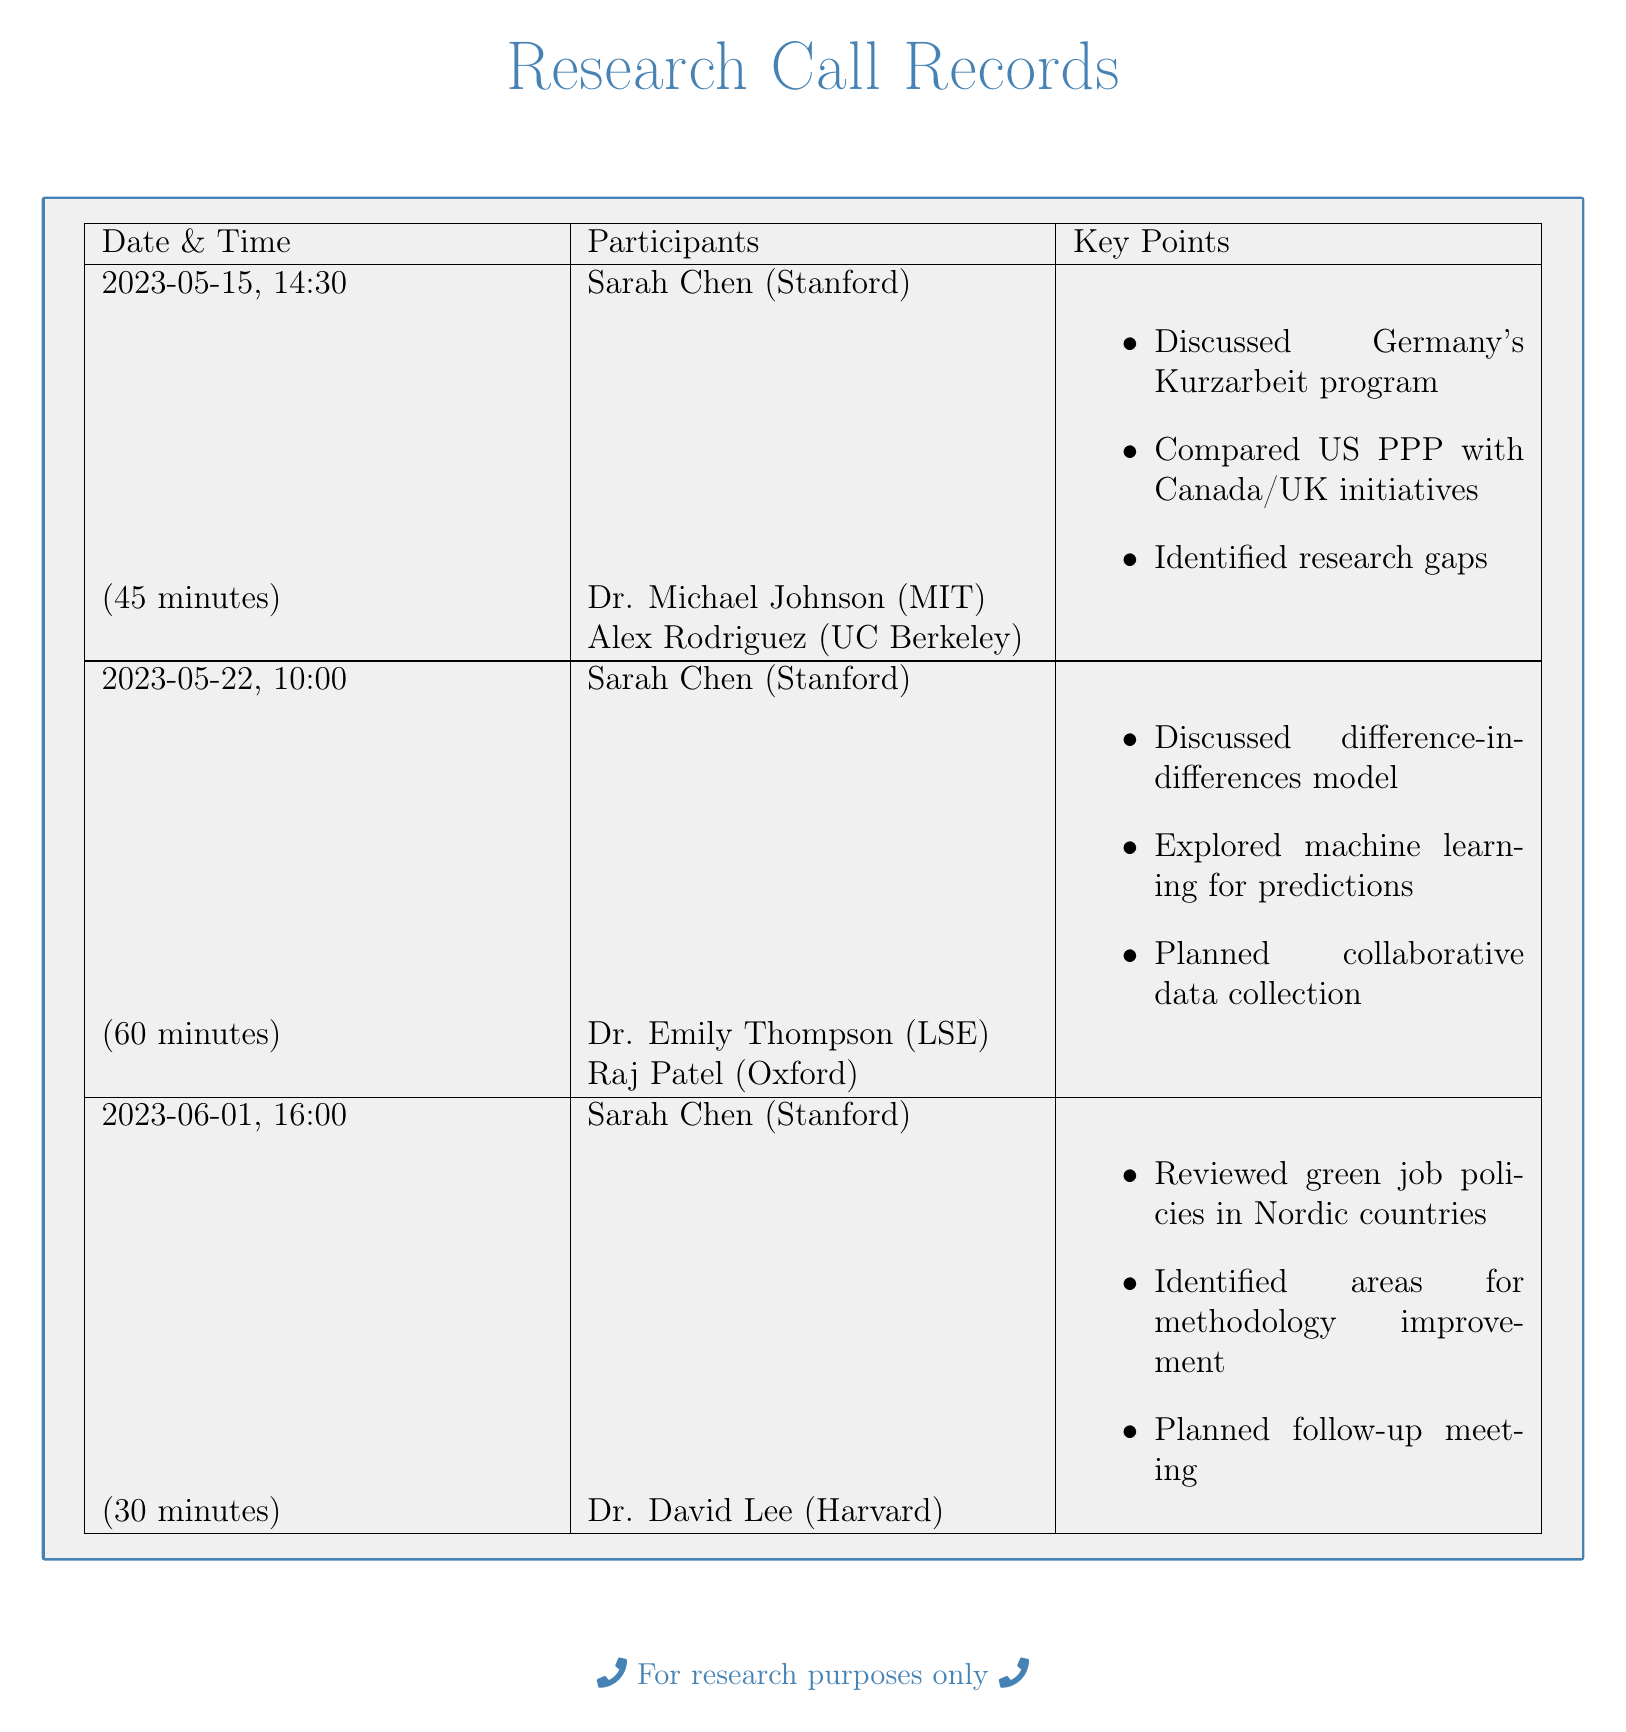what is the date of the first conference call? The date of the first conference call is stated in the document as May 15, 2023.
Answer: May 15, 2023 who is one of the participants in the second call? The participants listed for the second call include Dr. Emily Thompson from LSE.
Answer: Dr. Emily Thompson how long did the third call last? The duration of the third call is noted in the document as 30 minutes.
Answer: 30 minutes which program was discussed in the first call? In the first call, Germany's Kurzarbeit program was discussed as one of the key points.
Answer: Germany's Kurzarbeit program what was a focus area in the second call? The document mentions that exploring machine learning for predictions was a focus area in the second call.
Answer: machine learning for predictions who participated in the call on June 1? The participants are listed, and Dr. David Lee from Harvard was involved in the call on June 1.
Answer: Dr. David Lee how many participants were in the first call? The document states that there were three participants in the first call.
Answer: three participants which country’s green job policies were reviewed in the third call? The third call included a review of green job policies in Nordic countries according to the document.
Answer: Nordic countries what was identified in the first call? The first call identified research gaps for further exploration.
Answer: research gaps 